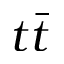<formula> <loc_0><loc_0><loc_500><loc_500>t \bar { t }</formula> 